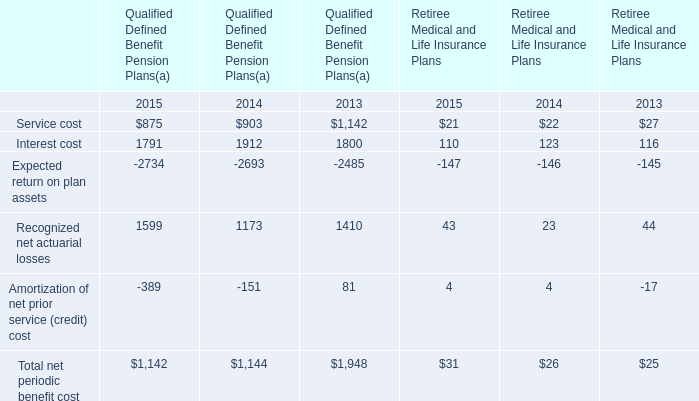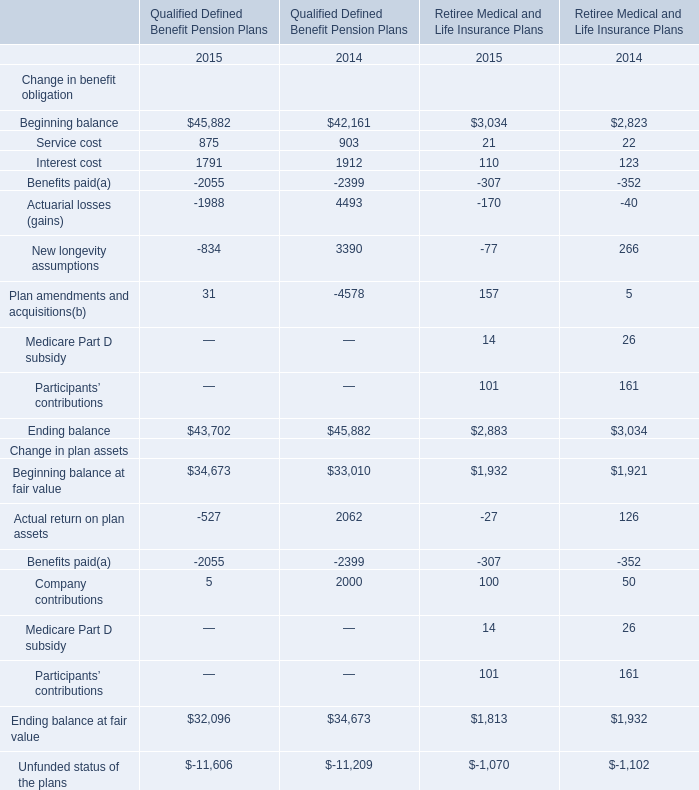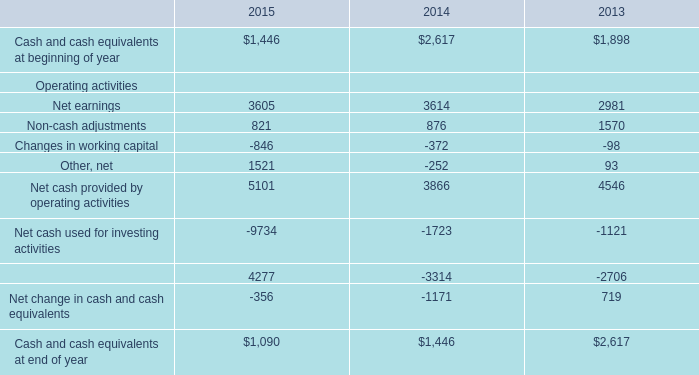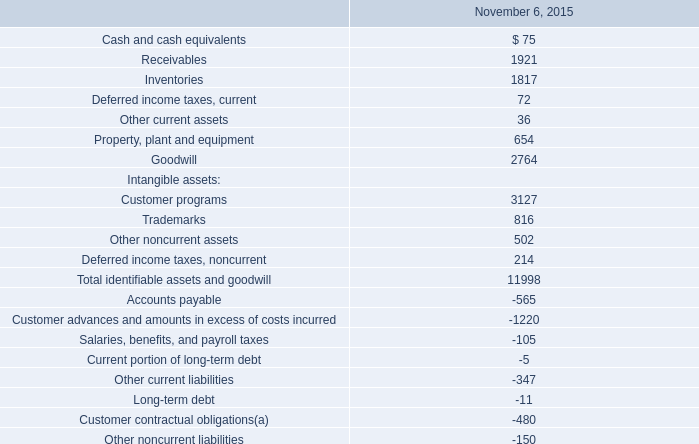How many elements for Qualified Defined Benefit Pension Plans show negative value in 2015? 
Answer: 6. 